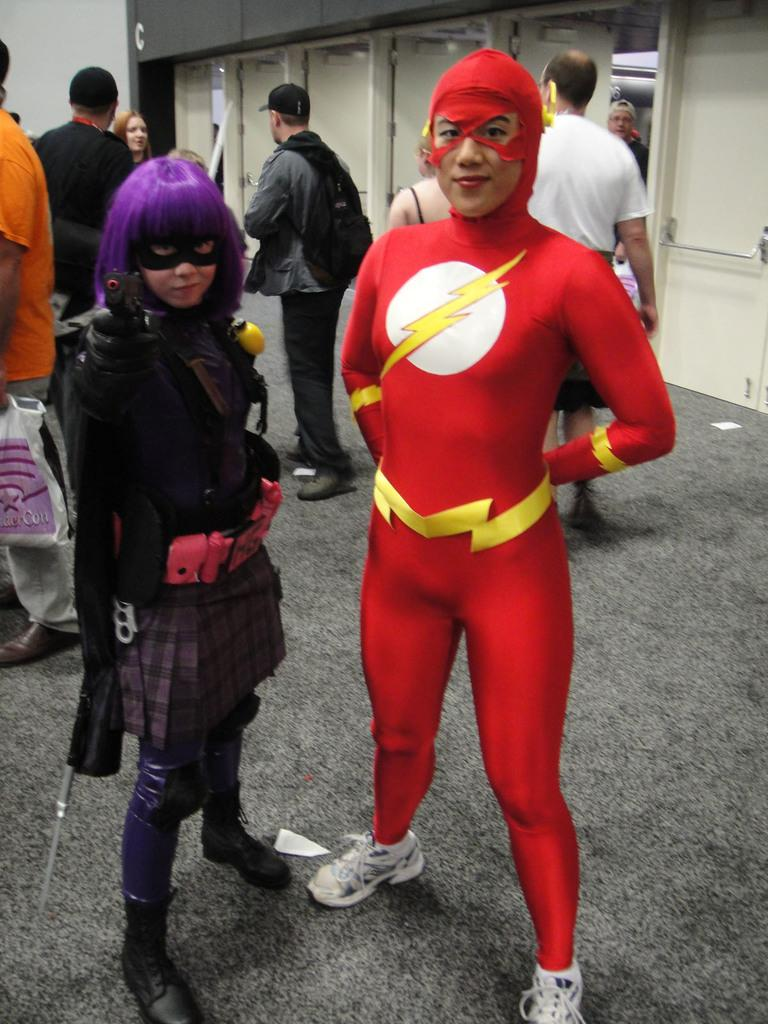How many people are present in the image? There are two persons in the image. Where are the persons located in the image? The persons are in the middle of the image. What can be observed about the clothing of the persons? The persons are wearing different kinds of dresses. What type of crib is visible in the image? There is no crib present in the image. 